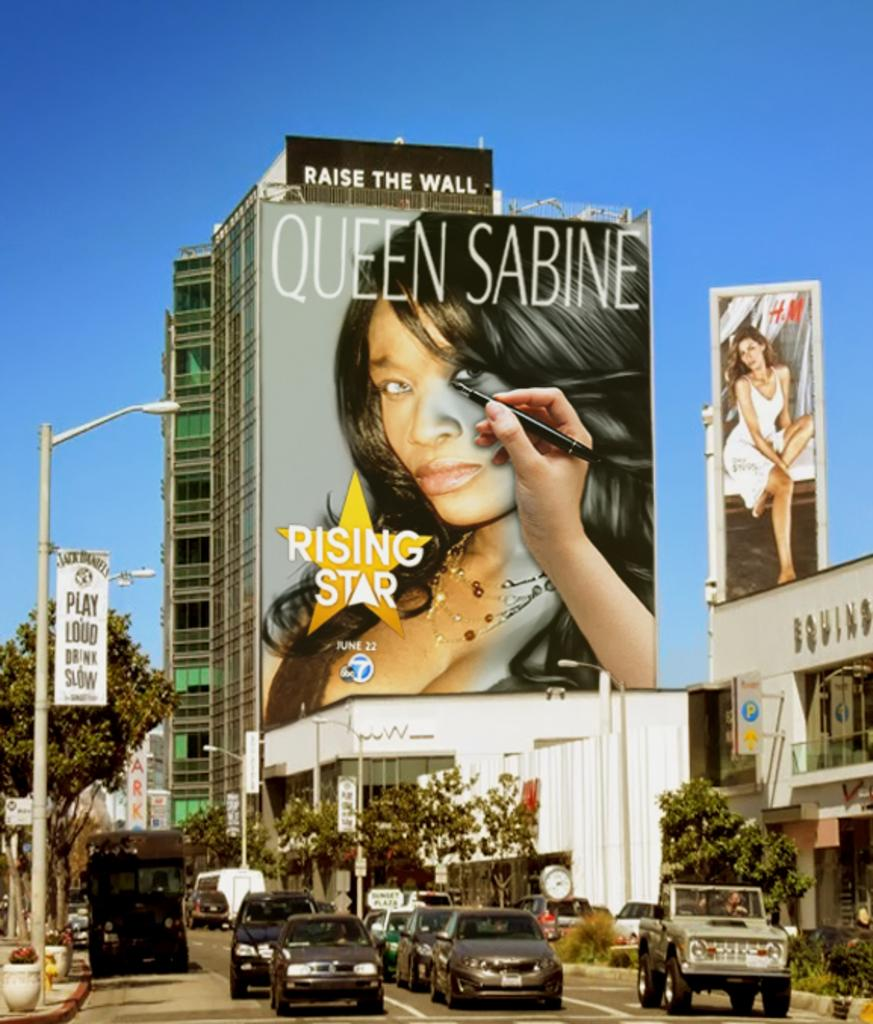<image>
Share a concise interpretation of the image provided. A large billboard on a building featuring Queen Sabine 